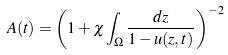Convert formula to latex. <formula><loc_0><loc_0><loc_500><loc_500>A ( t ) = \left ( 1 + \chi \int _ { \Omega } \frac { d z } { 1 - u ( z , t ) } \right ) ^ { - 2 }</formula> 